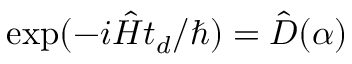<formula> <loc_0><loc_0><loc_500><loc_500>\exp ( - i \hat { H } t _ { d } / \hbar { ) } = \hat { D } ( \alpha )</formula> 